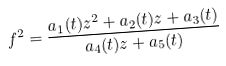<formula> <loc_0><loc_0><loc_500><loc_500>f ^ { 2 } = \frac { a _ { 1 } ( t ) z ^ { 2 } + a _ { 2 } ( t ) z + a _ { 3 } ( t ) } { a _ { 4 } ( t ) z + a _ { 5 } ( t ) }</formula> 